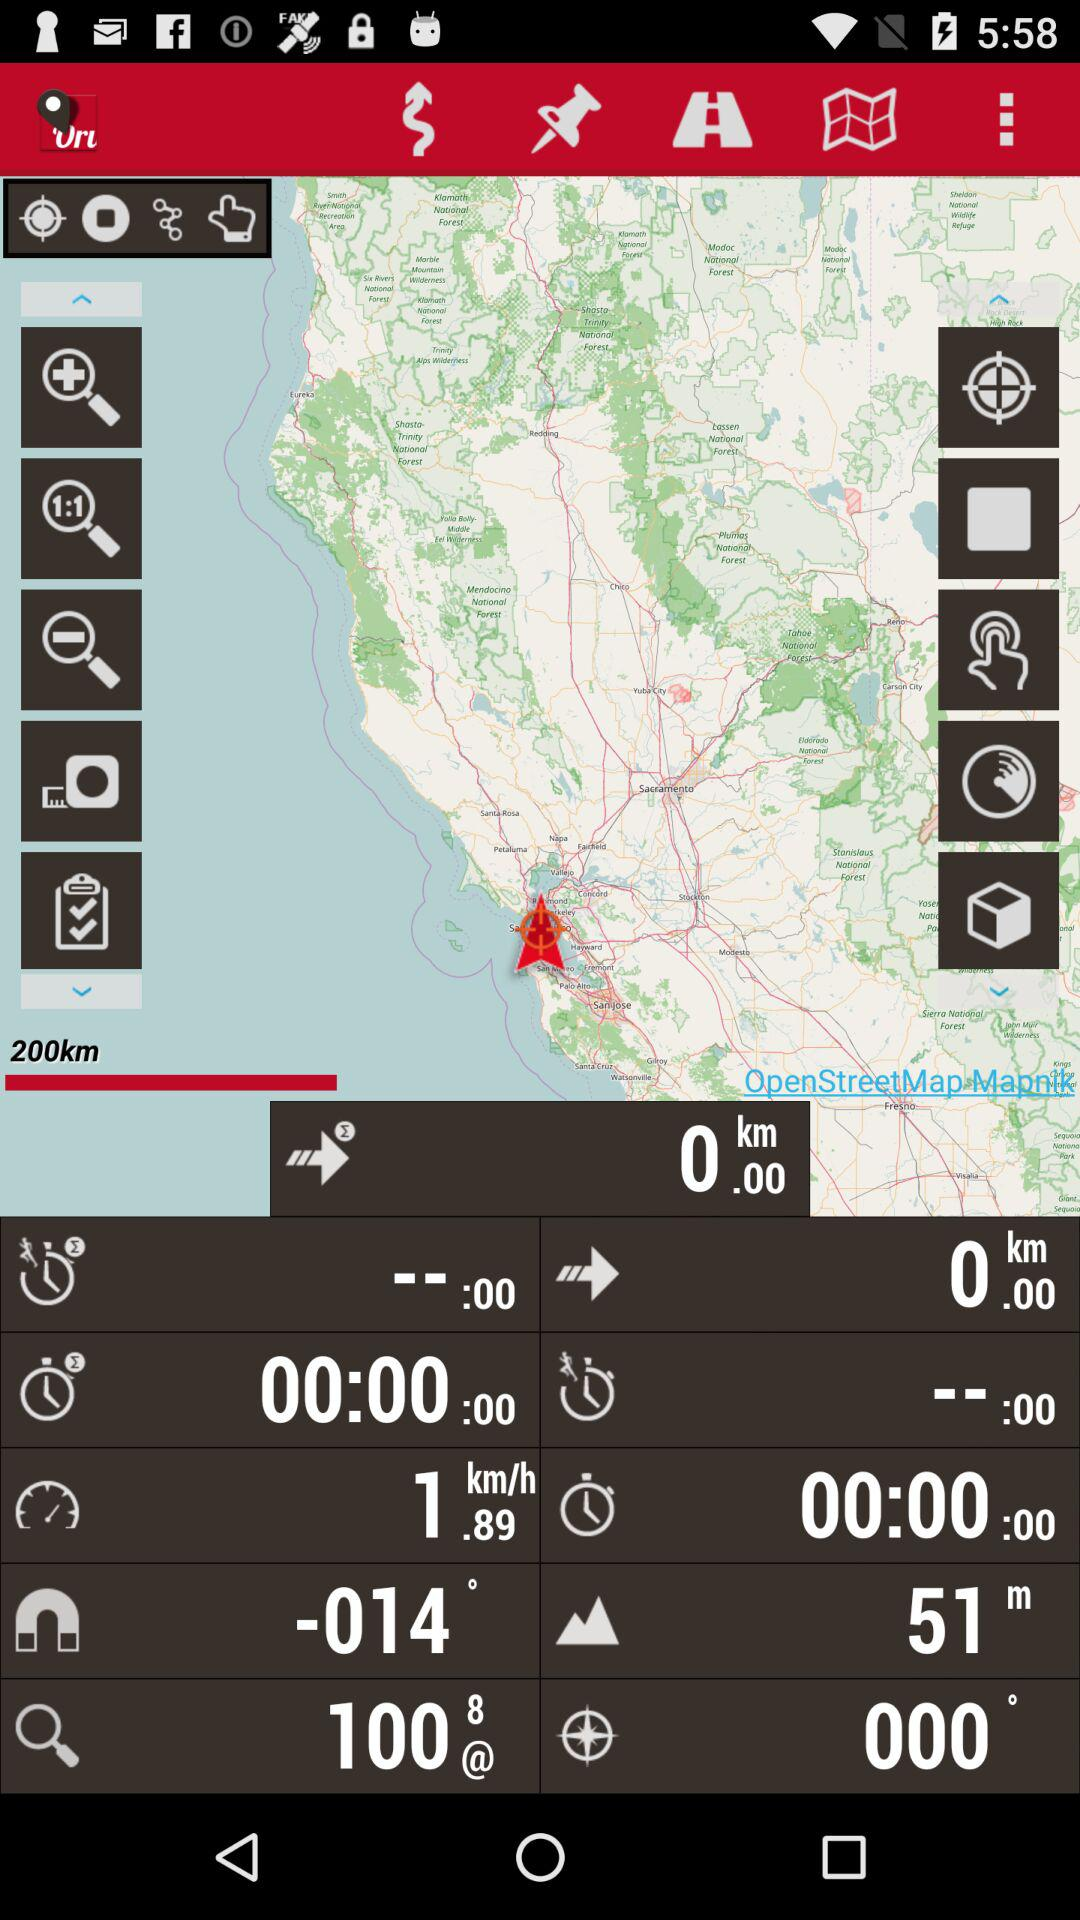What is the magnetic effect?
When the provided information is insufficient, respond with <no answer>. <no answer> 